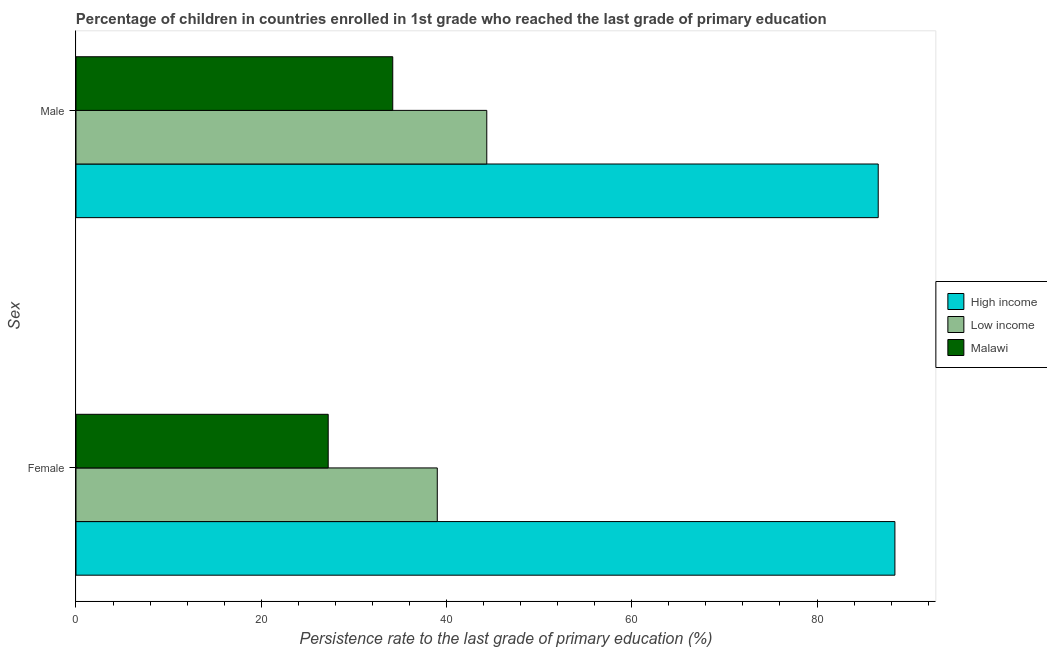How many different coloured bars are there?
Your answer should be very brief. 3. How many groups of bars are there?
Your response must be concise. 2. Are the number of bars per tick equal to the number of legend labels?
Give a very brief answer. Yes. Are the number of bars on each tick of the Y-axis equal?
Your answer should be very brief. Yes. What is the persistence rate of female students in Low income?
Your answer should be compact. 39. Across all countries, what is the maximum persistence rate of female students?
Your answer should be very brief. 88.41. Across all countries, what is the minimum persistence rate of female students?
Give a very brief answer. 27.23. In which country was the persistence rate of male students maximum?
Provide a short and direct response. High income. In which country was the persistence rate of female students minimum?
Your response must be concise. Malawi. What is the total persistence rate of male students in the graph?
Your response must be concise. 165.15. What is the difference between the persistence rate of male students in Low income and that in Malawi?
Keep it short and to the point. 10.15. What is the difference between the persistence rate of male students in High income and the persistence rate of female students in Low income?
Your answer should be compact. 47.6. What is the average persistence rate of male students per country?
Offer a terse response. 55.05. What is the difference between the persistence rate of male students and persistence rate of female students in Low income?
Keep it short and to the point. 5.34. In how many countries, is the persistence rate of male students greater than 84 %?
Your answer should be very brief. 1. What is the ratio of the persistence rate of male students in Low income to that in Malawi?
Offer a very short reply. 1.3. What does the 1st bar from the top in Female represents?
Your answer should be very brief. Malawi. How many bars are there?
Give a very brief answer. 6. Are all the bars in the graph horizontal?
Keep it short and to the point. Yes. How many countries are there in the graph?
Make the answer very short. 3. Are the values on the major ticks of X-axis written in scientific E-notation?
Your answer should be very brief. No. Does the graph contain grids?
Ensure brevity in your answer.  No. How are the legend labels stacked?
Your answer should be very brief. Vertical. What is the title of the graph?
Give a very brief answer. Percentage of children in countries enrolled in 1st grade who reached the last grade of primary education. What is the label or title of the X-axis?
Make the answer very short. Persistence rate to the last grade of primary education (%). What is the label or title of the Y-axis?
Keep it short and to the point. Sex. What is the Persistence rate to the last grade of primary education (%) of High income in Female?
Offer a very short reply. 88.41. What is the Persistence rate to the last grade of primary education (%) of Low income in Female?
Provide a short and direct response. 39. What is the Persistence rate to the last grade of primary education (%) in Malawi in Female?
Offer a terse response. 27.23. What is the Persistence rate to the last grade of primary education (%) in High income in Male?
Your response must be concise. 86.6. What is the Persistence rate to the last grade of primary education (%) in Low income in Male?
Offer a terse response. 44.35. What is the Persistence rate to the last grade of primary education (%) of Malawi in Male?
Offer a terse response. 34.2. Across all Sex, what is the maximum Persistence rate to the last grade of primary education (%) in High income?
Make the answer very short. 88.41. Across all Sex, what is the maximum Persistence rate to the last grade of primary education (%) in Low income?
Your answer should be compact. 44.35. Across all Sex, what is the maximum Persistence rate to the last grade of primary education (%) of Malawi?
Offer a terse response. 34.2. Across all Sex, what is the minimum Persistence rate to the last grade of primary education (%) in High income?
Make the answer very short. 86.6. Across all Sex, what is the minimum Persistence rate to the last grade of primary education (%) in Low income?
Provide a succinct answer. 39. Across all Sex, what is the minimum Persistence rate to the last grade of primary education (%) of Malawi?
Provide a short and direct response. 27.23. What is the total Persistence rate to the last grade of primary education (%) of High income in the graph?
Offer a terse response. 175.01. What is the total Persistence rate to the last grade of primary education (%) of Low income in the graph?
Provide a succinct answer. 83.35. What is the total Persistence rate to the last grade of primary education (%) in Malawi in the graph?
Your answer should be compact. 61.42. What is the difference between the Persistence rate to the last grade of primary education (%) in High income in Female and that in Male?
Your answer should be compact. 1.8. What is the difference between the Persistence rate to the last grade of primary education (%) of Low income in Female and that in Male?
Ensure brevity in your answer.  -5.34. What is the difference between the Persistence rate to the last grade of primary education (%) of Malawi in Female and that in Male?
Provide a short and direct response. -6.97. What is the difference between the Persistence rate to the last grade of primary education (%) of High income in Female and the Persistence rate to the last grade of primary education (%) of Low income in Male?
Make the answer very short. 44.06. What is the difference between the Persistence rate to the last grade of primary education (%) in High income in Female and the Persistence rate to the last grade of primary education (%) in Malawi in Male?
Provide a short and direct response. 54.21. What is the difference between the Persistence rate to the last grade of primary education (%) in Low income in Female and the Persistence rate to the last grade of primary education (%) in Malawi in Male?
Your answer should be compact. 4.81. What is the average Persistence rate to the last grade of primary education (%) in High income per Sex?
Provide a succinct answer. 87.51. What is the average Persistence rate to the last grade of primary education (%) of Low income per Sex?
Give a very brief answer. 41.67. What is the average Persistence rate to the last grade of primary education (%) of Malawi per Sex?
Make the answer very short. 30.71. What is the difference between the Persistence rate to the last grade of primary education (%) in High income and Persistence rate to the last grade of primary education (%) in Low income in Female?
Your answer should be compact. 49.4. What is the difference between the Persistence rate to the last grade of primary education (%) in High income and Persistence rate to the last grade of primary education (%) in Malawi in Female?
Make the answer very short. 61.18. What is the difference between the Persistence rate to the last grade of primary education (%) in Low income and Persistence rate to the last grade of primary education (%) in Malawi in Female?
Your answer should be very brief. 11.77. What is the difference between the Persistence rate to the last grade of primary education (%) of High income and Persistence rate to the last grade of primary education (%) of Low income in Male?
Your answer should be compact. 42.26. What is the difference between the Persistence rate to the last grade of primary education (%) of High income and Persistence rate to the last grade of primary education (%) of Malawi in Male?
Provide a short and direct response. 52.41. What is the difference between the Persistence rate to the last grade of primary education (%) in Low income and Persistence rate to the last grade of primary education (%) in Malawi in Male?
Keep it short and to the point. 10.15. What is the ratio of the Persistence rate to the last grade of primary education (%) in High income in Female to that in Male?
Provide a succinct answer. 1.02. What is the ratio of the Persistence rate to the last grade of primary education (%) in Low income in Female to that in Male?
Offer a very short reply. 0.88. What is the ratio of the Persistence rate to the last grade of primary education (%) in Malawi in Female to that in Male?
Make the answer very short. 0.8. What is the difference between the highest and the second highest Persistence rate to the last grade of primary education (%) in High income?
Ensure brevity in your answer.  1.8. What is the difference between the highest and the second highest Persistence rate to the last grade of primary education (%) of Low income?
Your answer should be very brief. 5.34. What is the difference between the highest and the second highest Persistence rate to the last grade of primary education (%) of Malawi?
Provide a short and direct response. 6.97. What is the difference between the highest and the lowest Persistence rate to the last grade of primary education (%) in High income?
Offer a very short reply. 1.8. What is the difference between the highest and the lowest Persistence rate to the last grade of primary education (%) in Low income?
Your answer should be very brief. 5.34. What is the difference between the highest and the lowest Persistence rate to the last grade of primary education (%) in Malawi?
Your answer should be very brief. 6.97. 